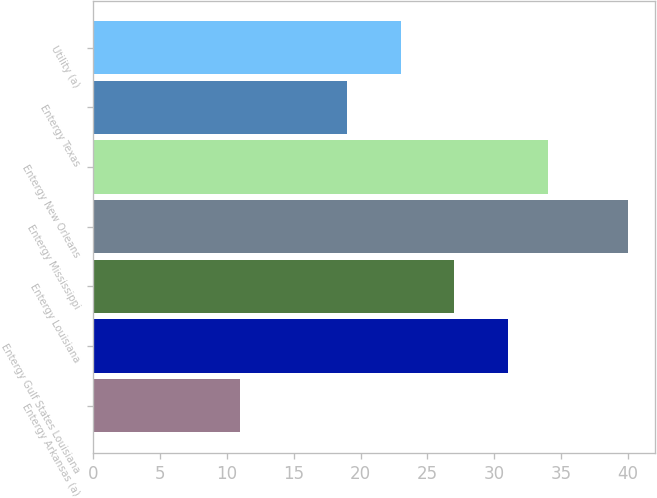Convert chart. <chart><loc_0><loc_0><loc_500><loc_500><bar_chart><fcel>Entergy Arkansas (a)<fcel>Entergy Gulf States Louisiana<fcel>Entergy Louisiana<fcel>Entergy Mississippi<fcel>Entergy New Orleans<fcel>Entergy Texas<fcel>Utility (a)<nl><fcel>11<fcel>31<fcel>27<fcel>40<fcel>34<fcel>19<fcel>23<nl></chart> 